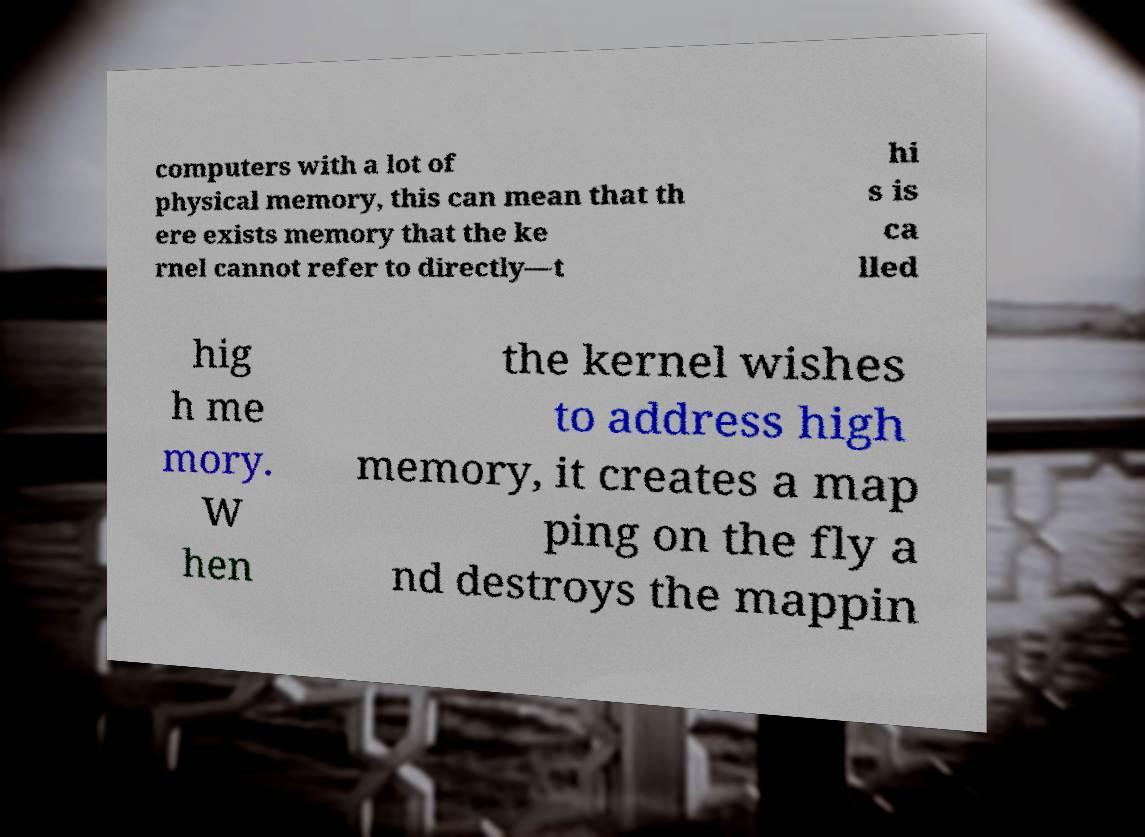Can you accurately transcribe the text from the provided image for me? computers with a lot of physical memory, this can mean that th ere exists memory that the ke rnel cannot refer to directly—t hi s is ca lled hig h me mory. W hen the kernel wishes to address high memory, it creates a map ping on the fly a nd destroys the mappin 